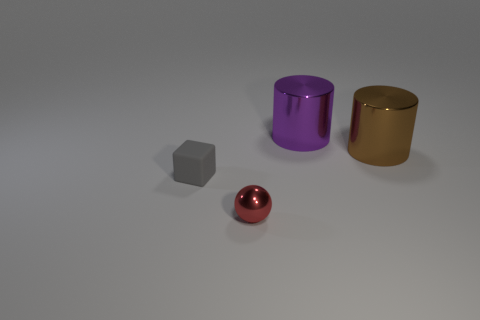Add 4 purple metallic objects. How many objects exist? 8 Subtract all blocks. How many objects are left? 3 Subtract all large purple shiny cylinders. Subtract all red metallic things. How many objects are left? 2 Add 4 brown metal things. How many brown metal things are left? 5 Add 4 matte objects. How many matte objects exist? 5 Subtract 0 blue blocks. How many objects are left? 4 